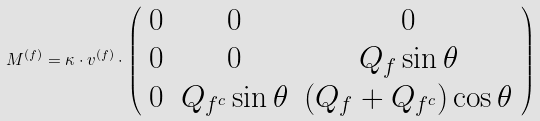Convert formula to latex. <formula><loc_0><loc_0><loc_500><loc_500>M ^ { ( f ) } = \kappa \cdot v ^ { ( f ) } \cdot \left ( \begin{array} { c c c } { 0 } & { 0 } & { 0 } \\ { 0 } & { 0 } & { { Q _ { f } \sin \theta } } \\ { 0 } & { { Q _ { f ^ { c } } \sin \theta } } & { { ( Q _ { f } + Q _ { f ^ { c } } ) \cos \theta } } \end{array} \right )</formula> 